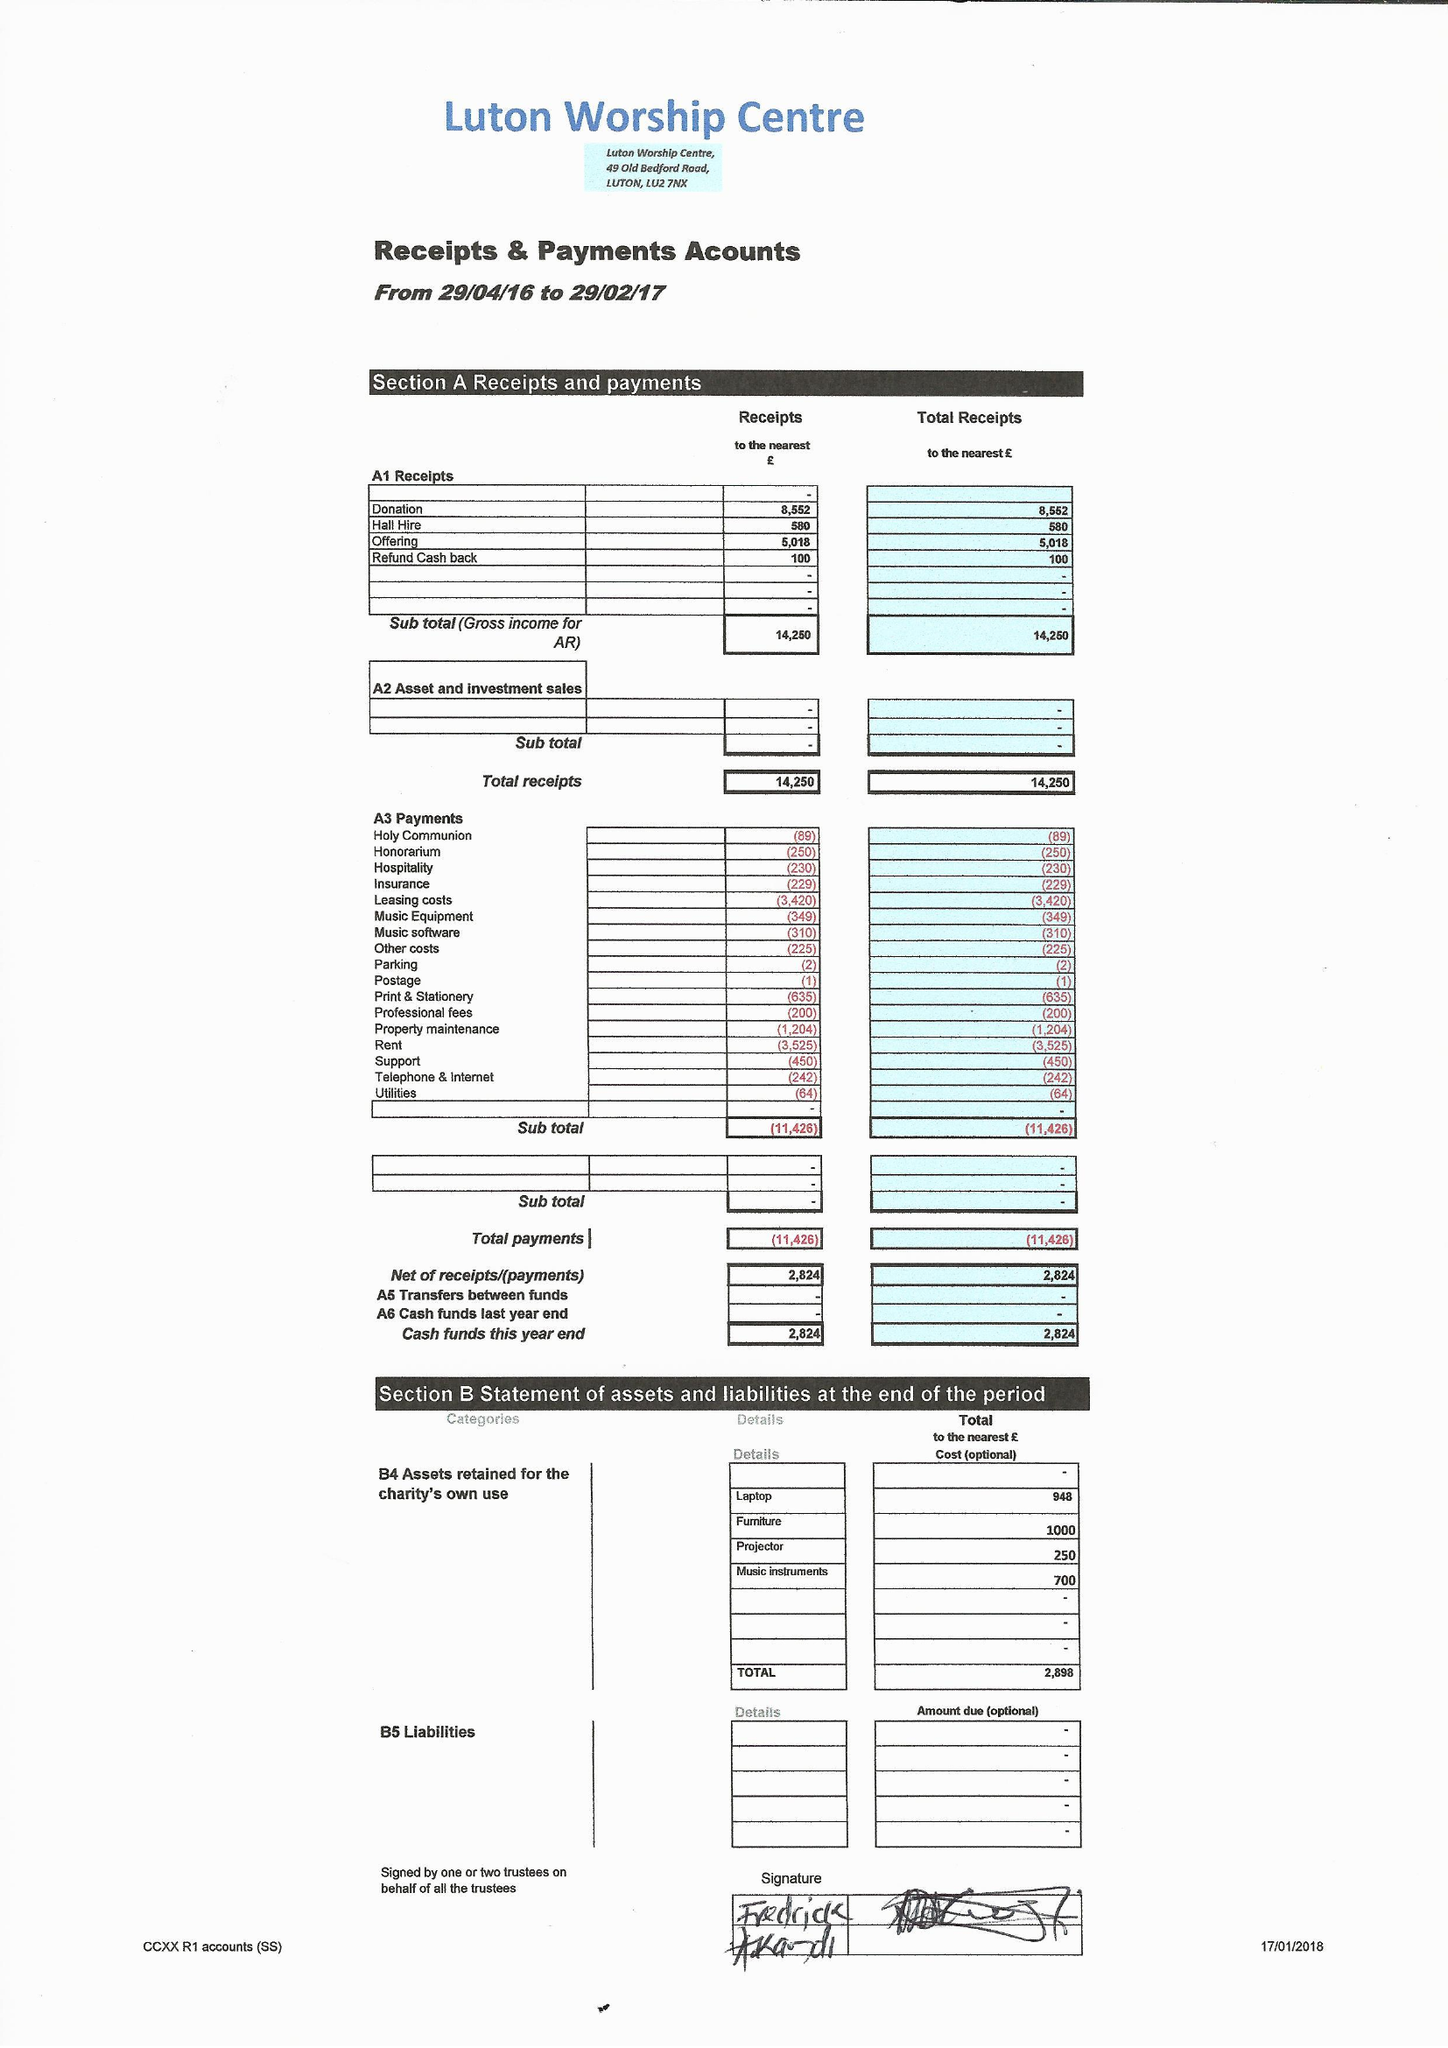What is the value for the report_date?
Answer the question using a single word or phrase. 2017-02-28 